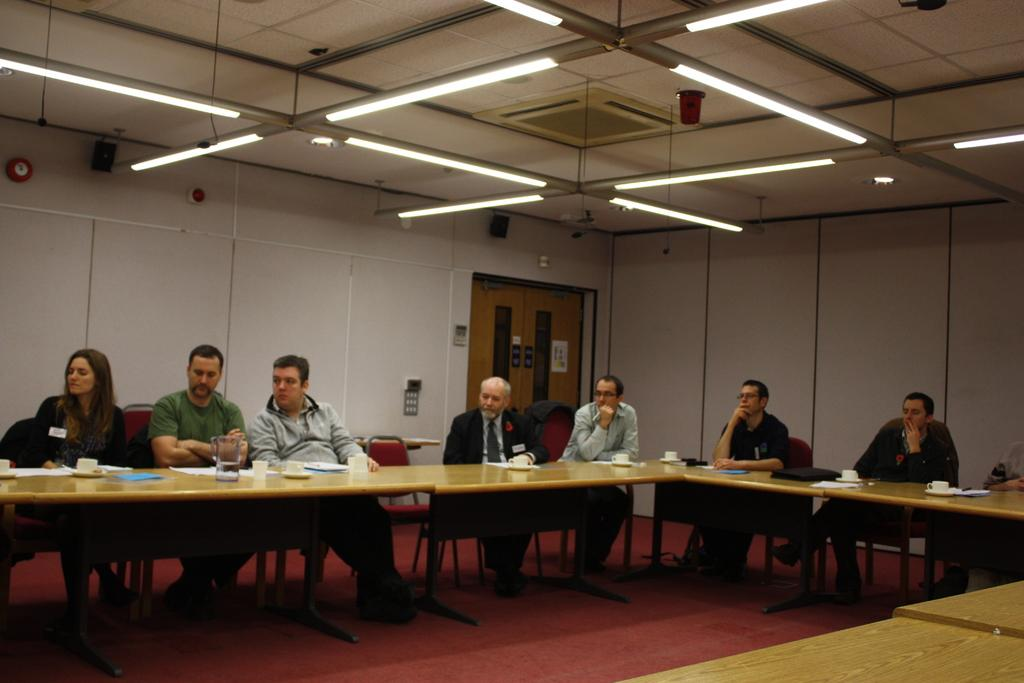How many people are in the image? There is a group of people in the image. What are the people doing in the image? The people are sitting in the image. What is in front of the group of people? There is a table in front of the group. What can be found on the table? There is a coffee cup and a water jar on the table. What is visible to the right of the image? There is a door visible to the right of the image. What type of nut is being cracked by the people in the image? There is no nut present in the image; the people are sitting and there is a table with a coffee cup and a water jar. 